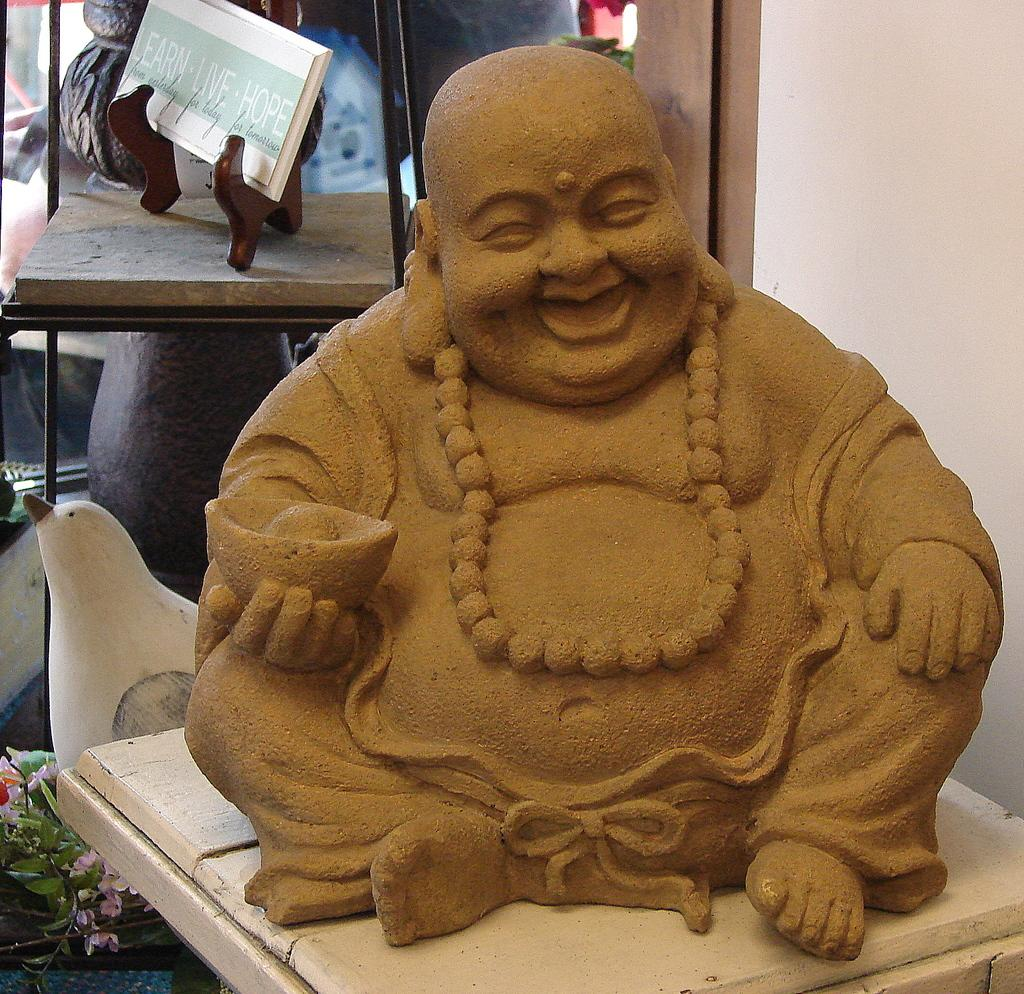What is the main subject in the center of the image? There is a statue in the center of the image. What can be seen in the background of the image? There is a book and a white-colored object in the background of the image. What type of bed can be seen in the image? There is no bed present in the image. 